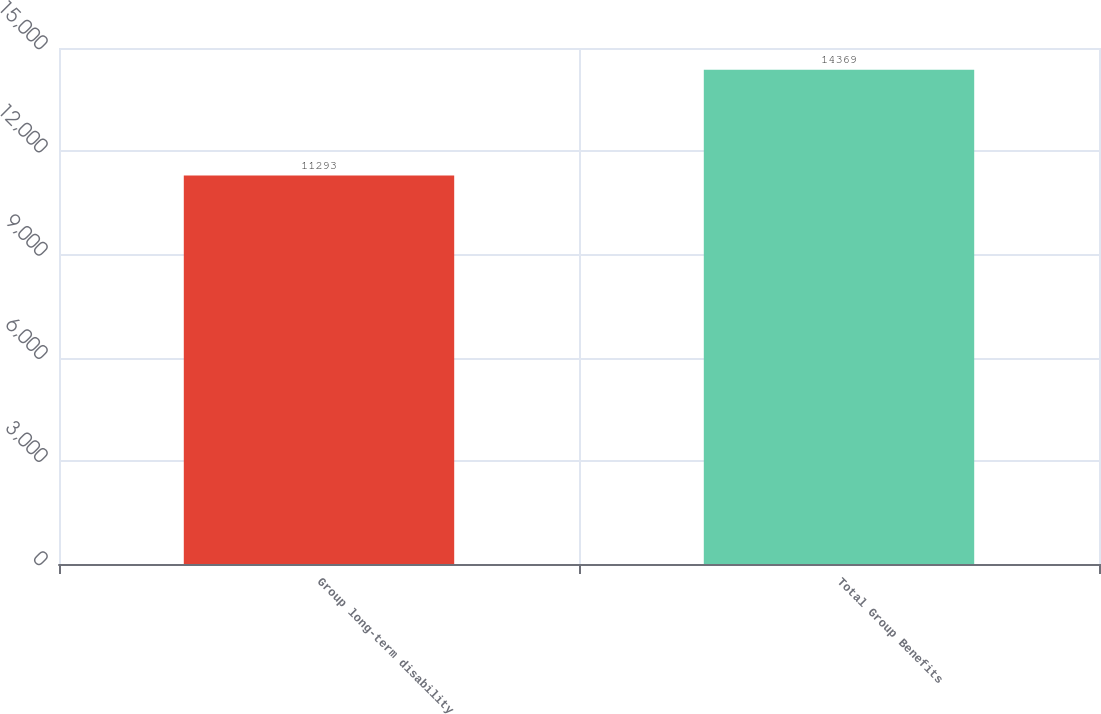<chart> <loc_0><loc_0><loc_500><loc_500><bar_chart><fcel>Group long-term disability<fcel>Total Group Benefits<nl><fcel>11293<fcel>14369<nl></chart> 